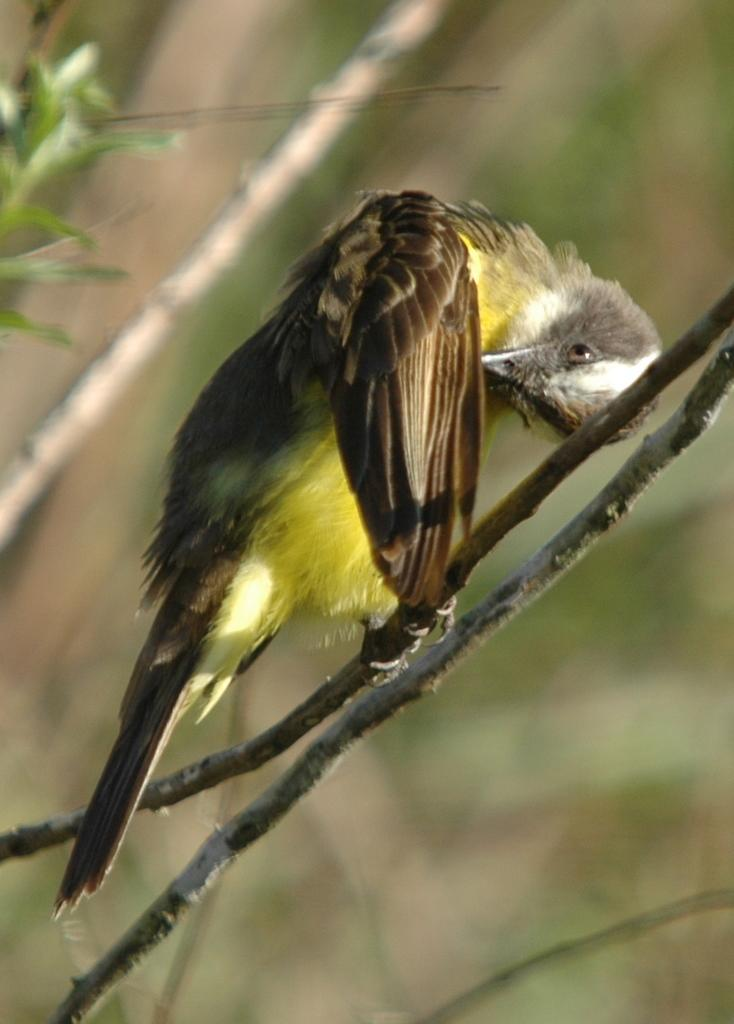Where was the picture taken? The picture was clicked outside. What is the main subject of the image? There is a bird in the center of the image. What is the bird standing on? The bird is standing on a stem. What can be seen in the background of the image? There are plants and stems in the background of the image, as well as other objects. How many plates are visible in the image? There are no plates visible in the image. What type of flight is the bird taking in the image? The image does not show the bird in flight; it is standing on a stem. 